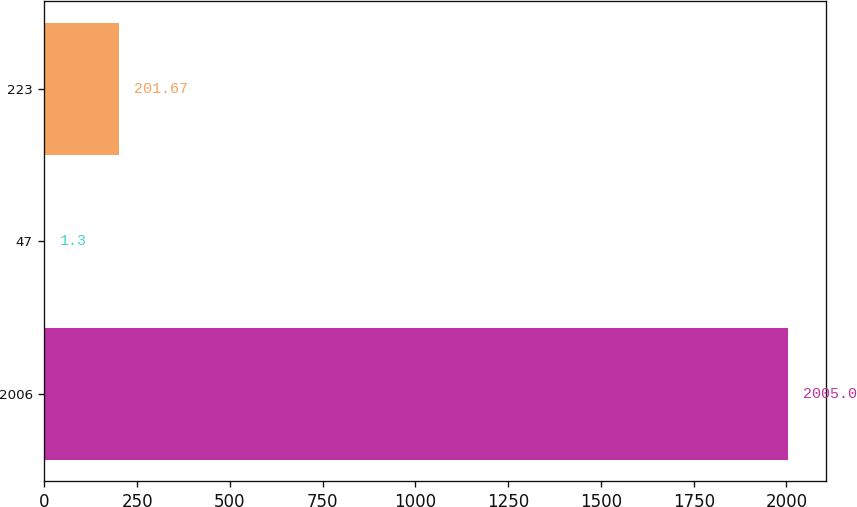Convert chart to OTSL. <chart><loc_0><loc_0><loc_500><loc_500><bar_chart><fcel>2006<fcel>47<fcel>223<nl><fcel>2005<fcel>1.3<fcel>201.67<nl></chart> 